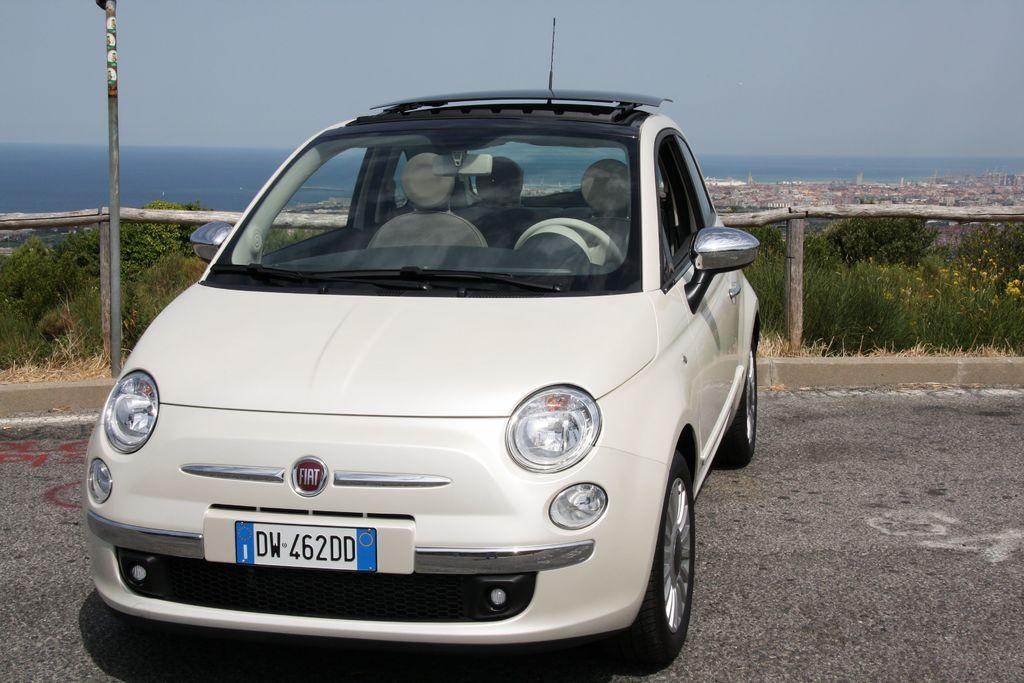What color is the car in the image? The car in the image is white. Where is the car located in the image? The car is in the front of the image. What can be seen in the background of the image? There are trees, a wooden railing, a pole, and the sky visible in the background of the image. What does the car need to do in the image? The car does not need to do anything in the image, as it is a static object. What is the car using its mouth for in the image? Cars do not have mouths, so this question is not applicable to the image. 